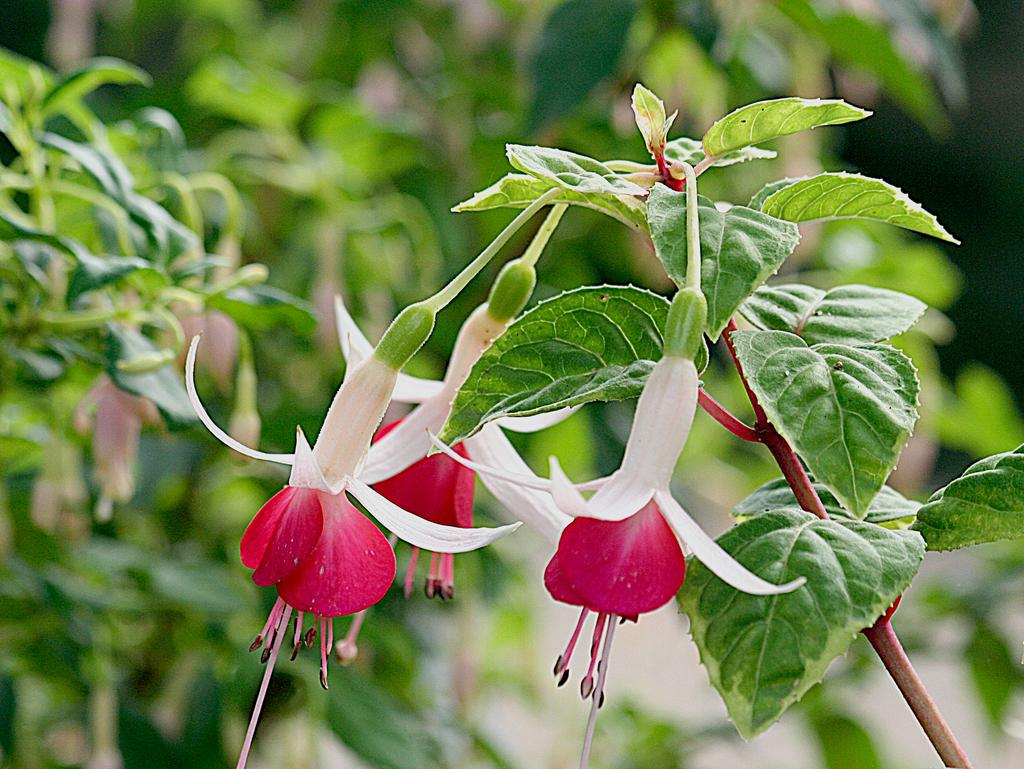What type of vegetation can be seen in the image? There are trees in the image. Are there any plants with flowers in the image? Yes, there are flowers on a plant in the image. What type of shoe can be seen hanging from the tree in the image? There is no shoe present in the image; it only features trees and a plant with flowers. 